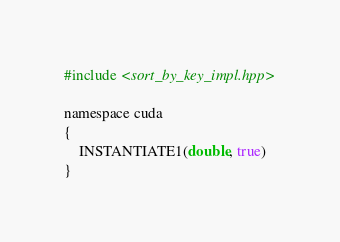Convert code to text. <code><loc_0><loc_0><loc_500><loc_500><_Cuda_>#include <sort_by_key_impl.hpp>

namespace cuda
{
    INSTANTIATE1(double, true)
}
</code> 